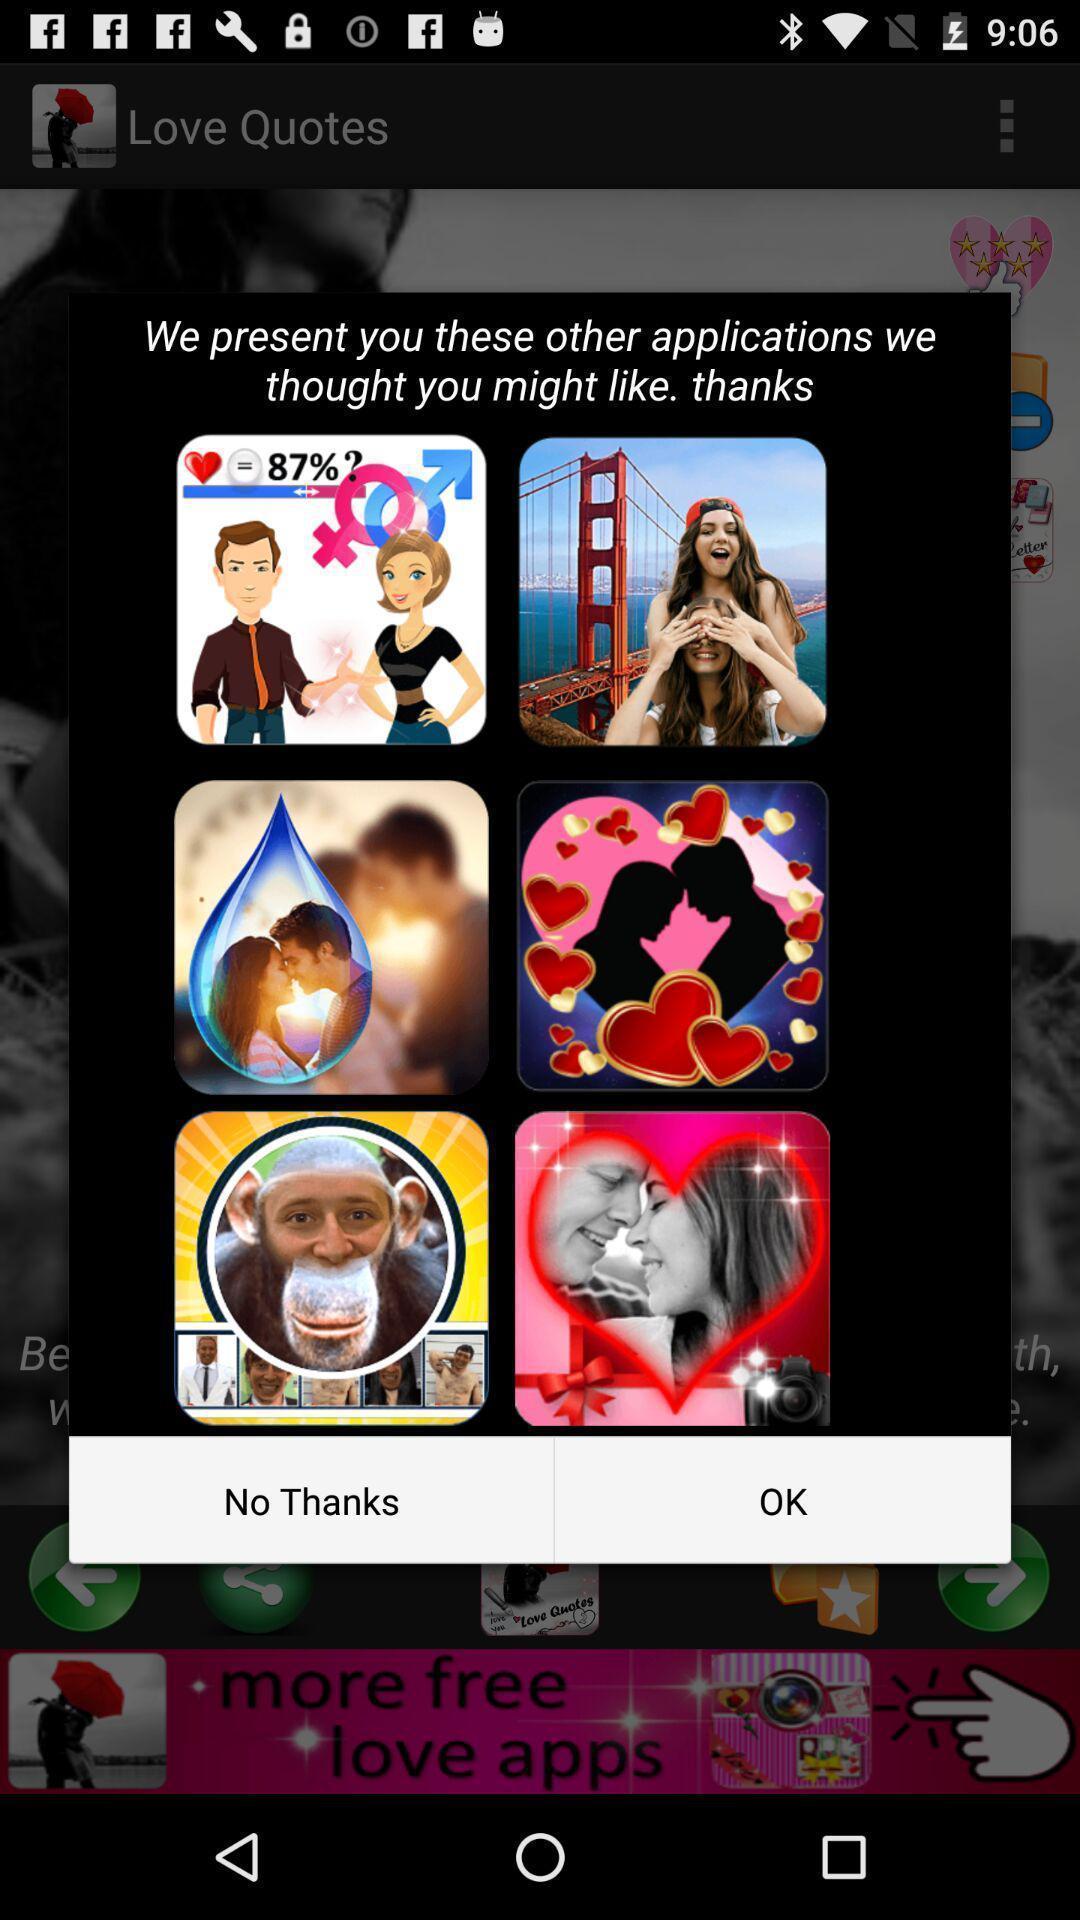Describe the content in this image. Popup of list of social apps in the application. 